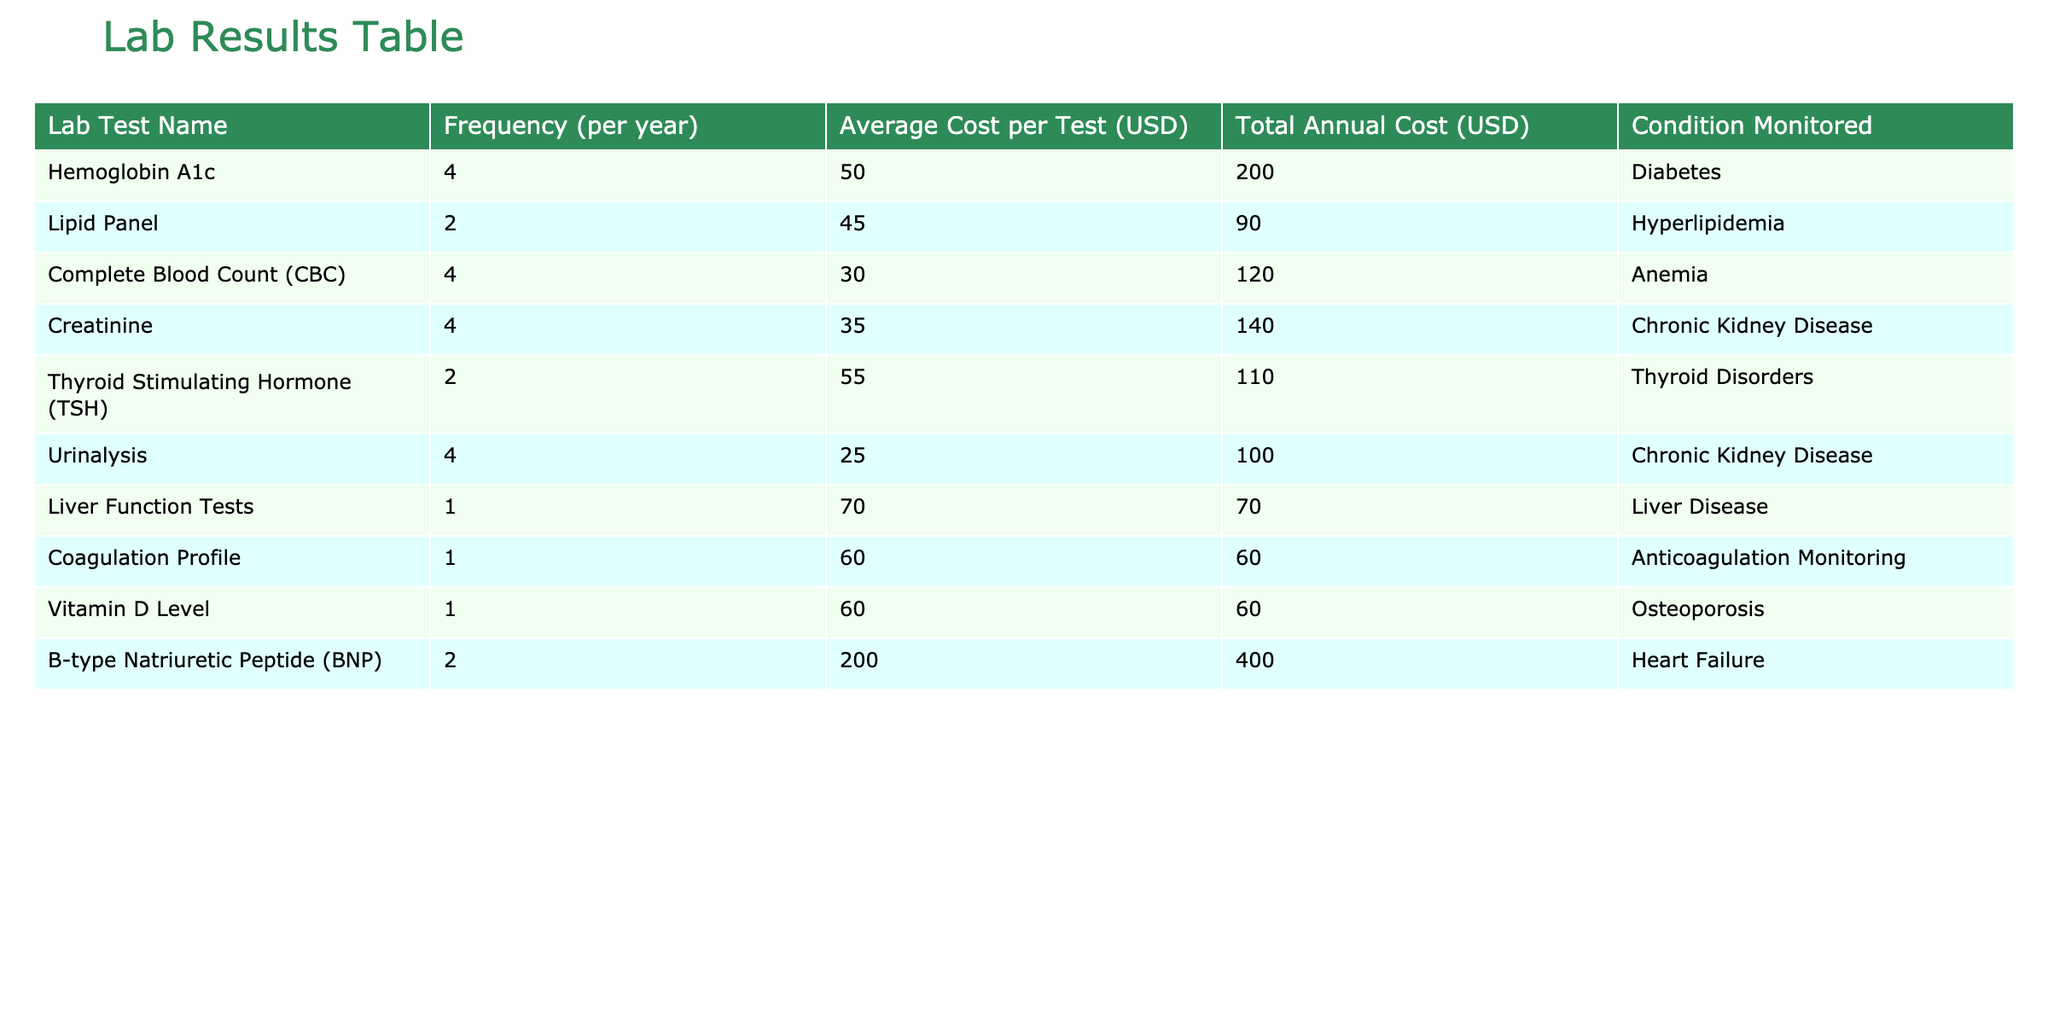What is the frequency of Hemoglobin A1c tests per year? The table lists the frequency for Hemoglobin A1c tests as 4 times per year.
Answer: 4 What is the average cost per test for the Lipid Panel? The average cost per test for the Lipid Panel is directly stated in the table as 45 USD.
Answer: 45 USD How much does the total annual cost for Thyroid Stimulating Hormone tests amount to? The table provides the total annual cost for Thyroid Stimulating Hormone tests as 110 USD, which is calculated from its frequency (2) multiplied by its average cost per test (55).
Answer: 110 USD Is the average cost per test greater for the B-type Natriuretic Peptide than for the Liver Function Tests? The average cost per test for B-type Natriuretic Peptide is 200 USD, while for Liver Function Tests, it is 70 USD. Since 200 is greater than 70, the answer is yes.
Answer: Yes Which test has the highest total annual cost and what is that cost? B-type Natriuretic Peptide has the highest total annual cost of 400 USD, as indicated in the table.
Answer: 400 USD What is the combined total annual cost for the tests related to Chronic Kidney Disease? The table shows the total annual costs for Creatinine (140 USD) and Urinalysis (100 USD). Adding these gives 140 + 100 = 240 USD for the combined total.
Answer: 240 USD Are there any tests that occur less frequently than once per year? The table does not list any tests with a frequency of less than 1 per year; all listed tests happen at least once per year.
Answer: No Which condition monitored has the lowest average cost per test and what is that amount? Urinalysis has the lowest average cost per test at 25 USD, according to the data in the table.
Answer: 25 USD How many times per year is the Complete Blood Count (CBC) test performed compared to the Lipid Panel? Complete Blood Count (CBC) is performed 4 times per year while the Lipid Panel is performed 2 times per year. Therefore, CBC is performed twice as frequently as the Lipid Panel.
Answer: CBC is performed twice as frequently 